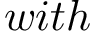<formula> <loc_0><loc_0><loc_500><loc_500>w i t h</formula> 